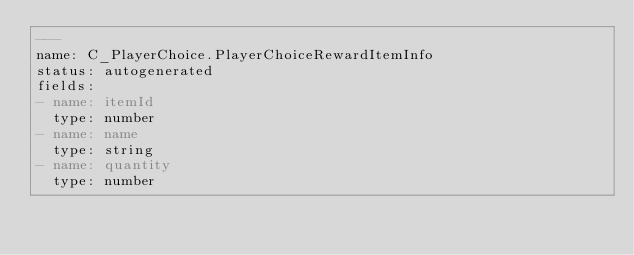<code> <loc_0><loc_0><loc_500><loc_500><_YAML_>---
name: C_PlayerChoice.PlayerChoiceRewardItemInfo
status: autogenerated
fields:
- name: itemId
  type: number
- name: name
  type: string
- name: quantity
  type: number
</code> 